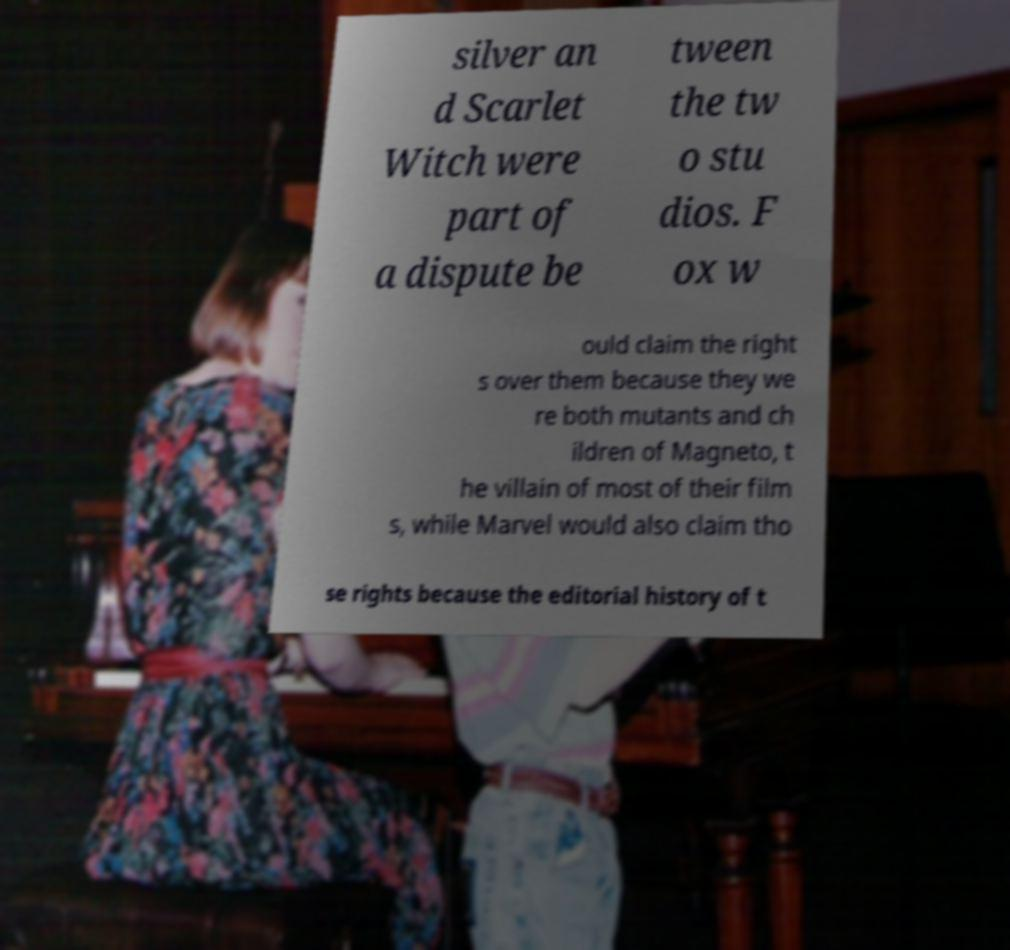Could you extract and type out the text from this image? silver an d Scarlet Witch were part of a dispute be tween the tw o stu dios. F ox w ould claim the right s over them because they we re both mutants and ch ildren of Magneto, t he villain of most of their film s, while Marvel would also claim tho se rights because the editorial history of t 